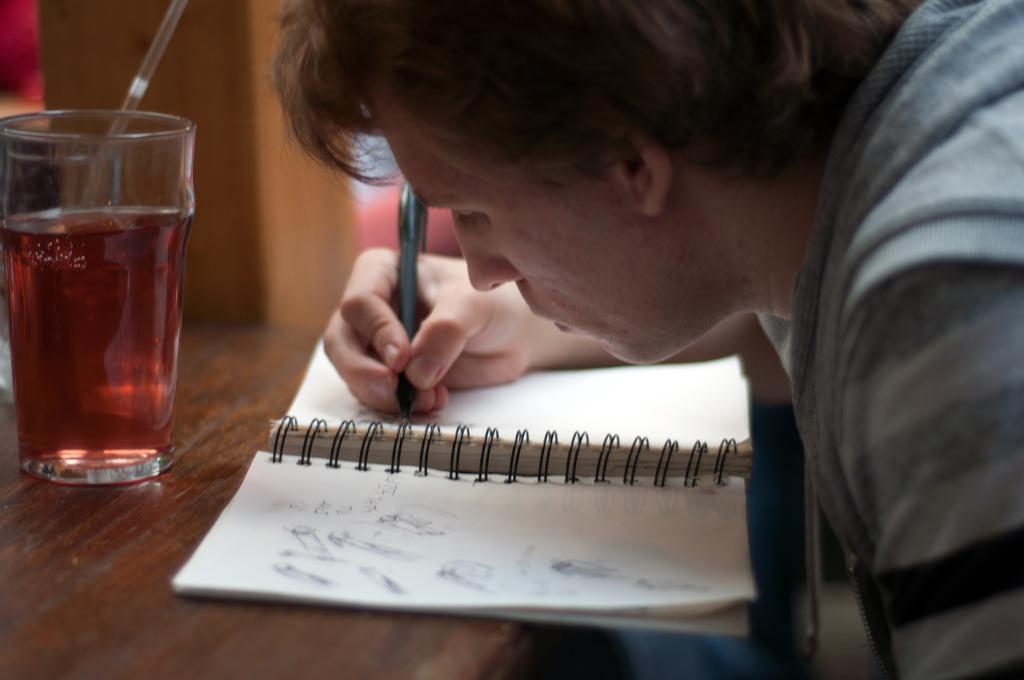Who is the person in the image? There is a man in the image. What is the man doing in the image? The man is writing on a book. Where is the book located in the image? The book is placed on a table. What else can be seen on the table in the image? There is a glass on the table. What is visible in the background of the image? There is a wall in the background of the image. Where is the lamp located in the image? There is no lamp present in the image. What type of cork can be seen in the image? There is no cork present in the image. 